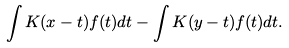<formula> <loc_0><loc_0><loc_500><loc_500>\int K ( x - t ) f ( t ) d t - \int K ( y - t ) f ( t ) d t .</formula> 